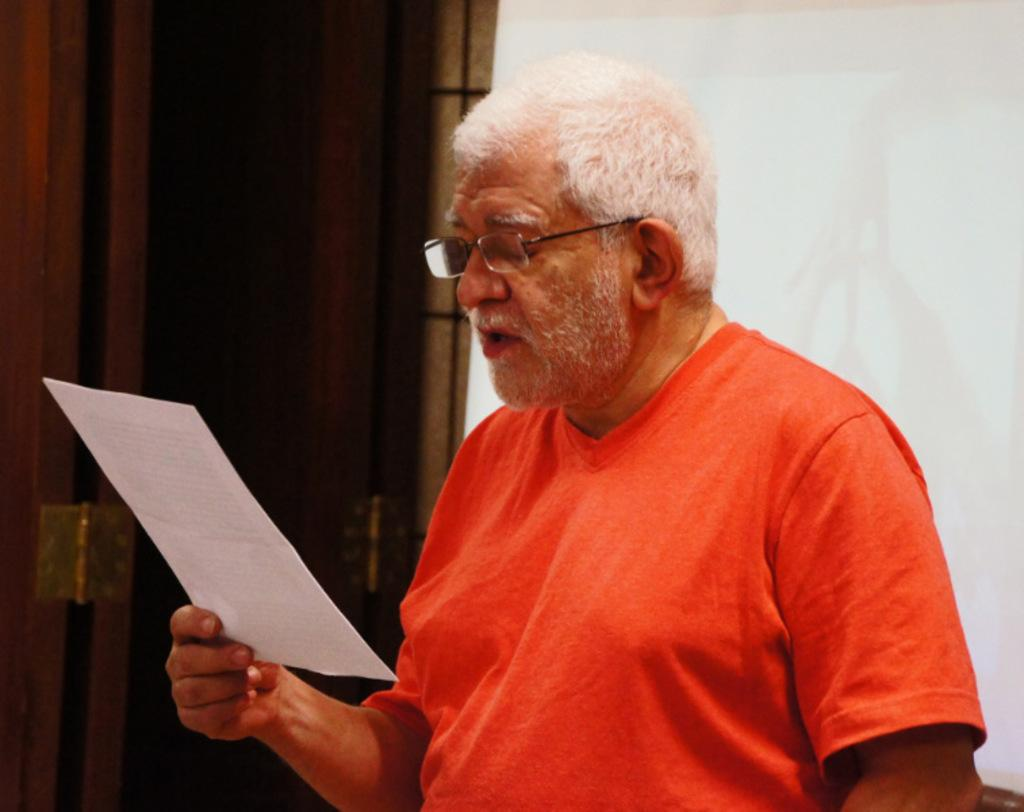What is the man in the image doing? The man is holding a paper and looking at it. What is the man wearing on his face? The man is wearing spectacles. What color is the t-shirt the man is wearing? The man is wearing an orange t-shirt. What can be seen on the left side of the image? There is a door on the left side of the image. What type of office furniture can be seen in the image? There is no office furniture present in the image. Is the man's hand holding anything other than the paper? The man's hand is only holding the paper, as mentioned in the facts. 